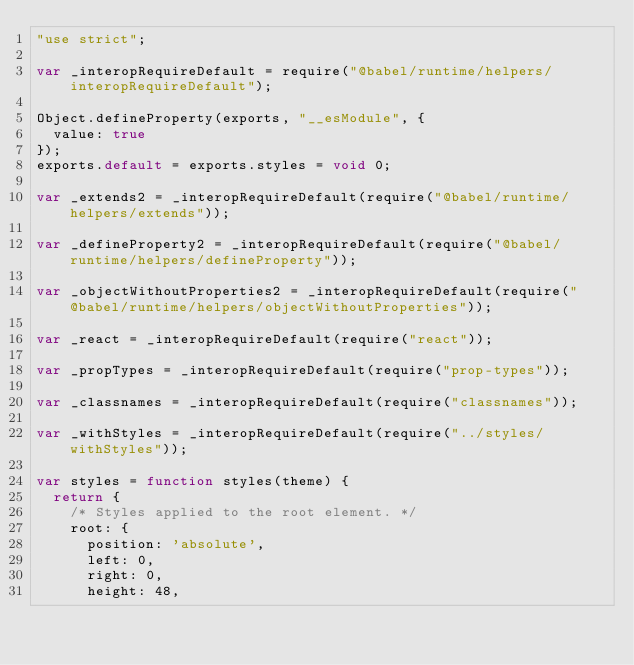Convert code to text. <code><loc_0><loc_0><loc_500><loc_500><_JavaScript_>"use strict";

var _interopRequireDefault = require("@babel/runtime/helpers/interopRequireDefault");

Object.defineProperty(exports, "__esModule", {
  value: true
});
exports.default = exports.styles = void 0;

var _extends2 = _interopRequireDefault(require("@babel/runtime/helpers/extends"));

var _defineProperty2 = _interopRequireDefault(require("@babel/runtime/helpers/defineProperty"));

var _objectWithoutProperties2 = _interopRequireDefault(require("@babel/runtime/helpers/objectWithoutProperties"));

var _react = _interopRequireDefault(require("react"));

var _propTypes = _interopRequireDefault(require("prop-types"));

var _classnames = _interopRequireDefault(require("classnames"));

var _withStyles = _interopRequireDefault(require("../styles/withStyles"));

var styles = function styles(theme) {
  return {
    /* Styles applied to the root element. */
    root: {
      position: 'absolute',
      left: 0,
      right: 0,
      height: 48,</code> 